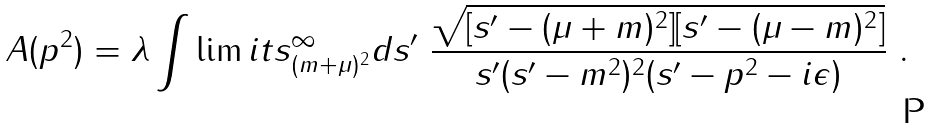<formula> <loc_0><loc_0><loc_500><loc_500>A ( p ^ { 2 } ) = \lambda \int \lim i t s _ { ( m + \mu ) ^ { 2 } } ^ { \infty } d s ^ { \prime } \ \frac { \sqrt { [ s ^ { \prime } - ( \mu + m ) ^ { 2 } ] [ s ^ { \prime } - ( \mu - m ) ^ { 2 } ] } } { s ^ { \prime } ( s ^ { \prime } - m ^ { 2 } ) ^ { 2 } ( s ^ { \prime } - p ^ { 2 } - i \epsilon ) } \ .</formula> 